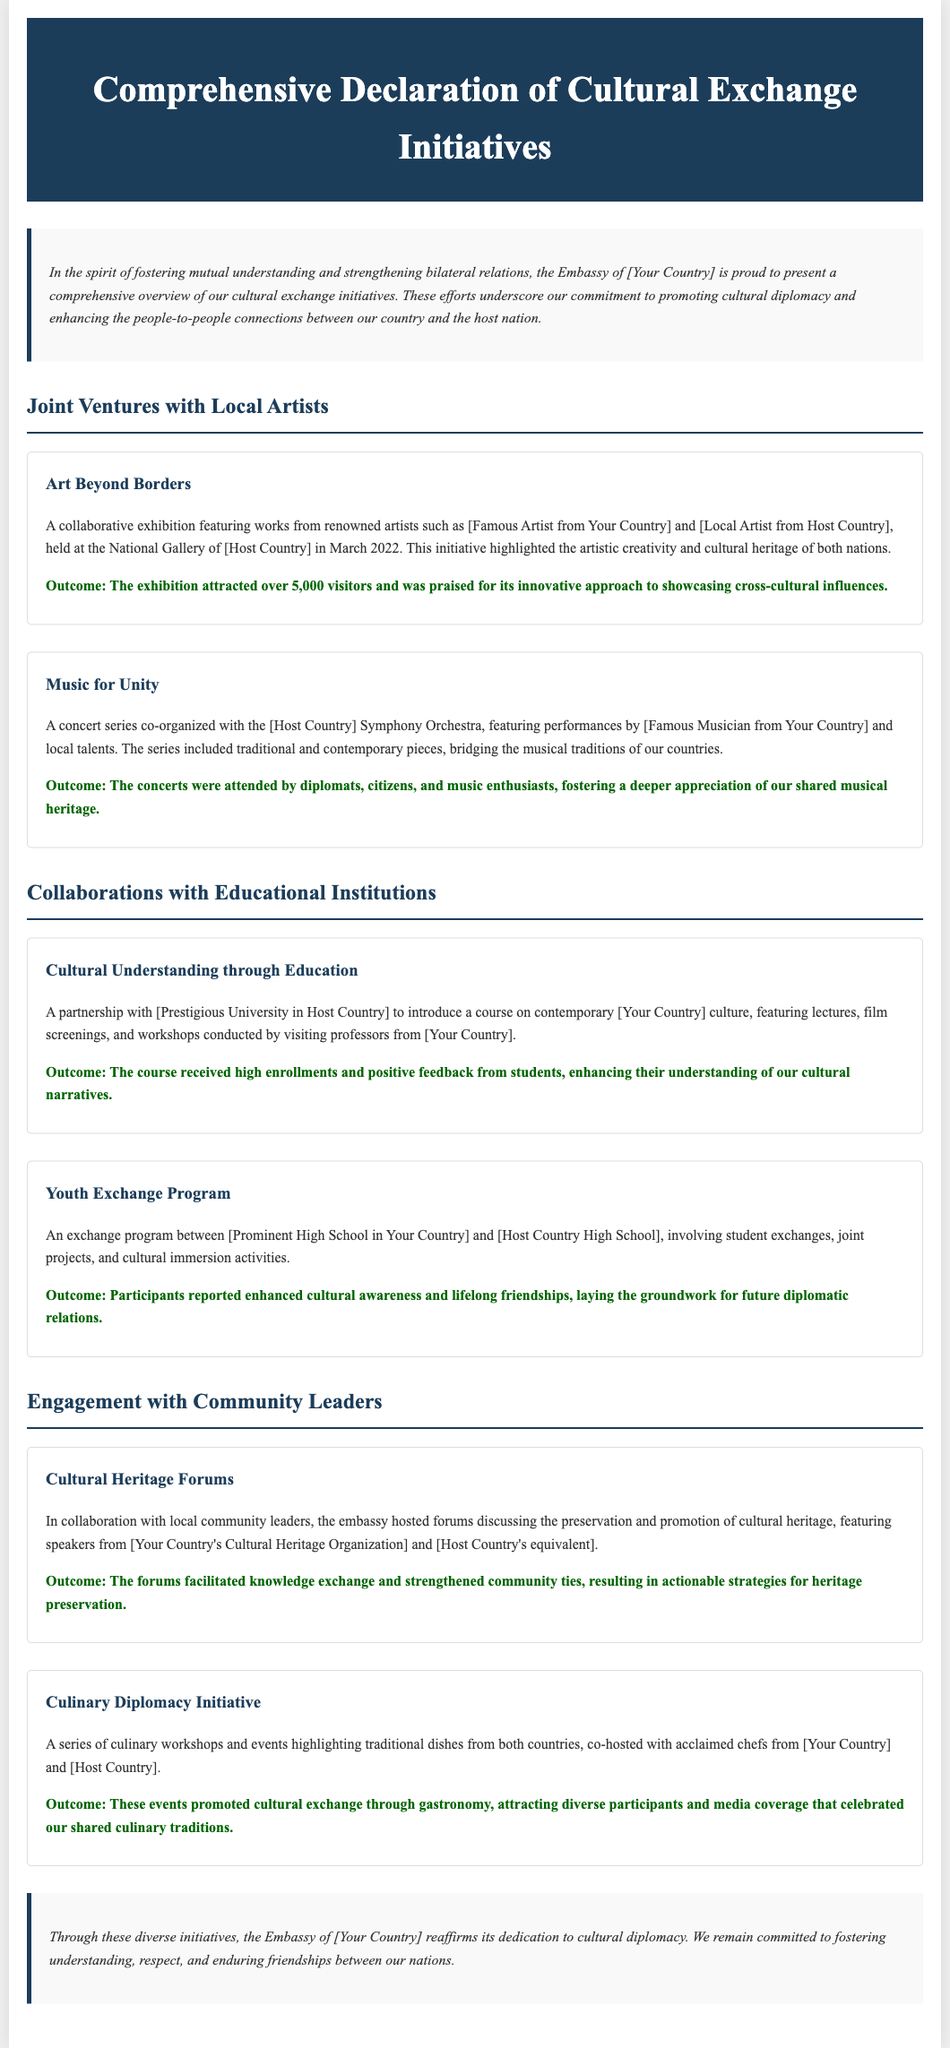What is the title of the document? The title is presented in the header section of the document.
Answer: Comprehensive Declaration of Cultural Exchange Initiatives When was the "Art Beyond Borders" exhibition held? The date of the exhibition is specified in the description.
Answer: March 2022 Who co-organized the "Music for Unity" concert series? The document specifies the collaborator for this initiative.
Answer: [Host Country] Symphony Orchestra What was the outcome of the "Cultural Understanding through Education" initiative? The outcome is directly mentioned in the initiative description.
Answer: High enrollments and positive feedback How many visitors attended the "Art Beyond Borders" exhibition? The number of visitors is stated in the outcome of the initiative.
Answer: Over 5,000 visitors Which two types of events were part of the Culinary Diplomacy Initiative? The document describes the nature of the events in this initiative.
Answer: Culinary workshops and events What theme did the Cultural Heritage Forums focus on? The focus of the forums is clearly outlined in the initiative description.
Answer: Preservation and promotion of cultural heritage How did participants feel about the Youth Exchange Program? The feelings of participants are summarized in the outcome statement.
Answer: Enhanced cultural awareness and lifelong friendships Who were the speakers at the Cultural Heritage Forums? The document lists the organizations represented by the speakers.
Answer: [Your Country's Cultural Heritage Organization] and [Host Country's equivalent] 